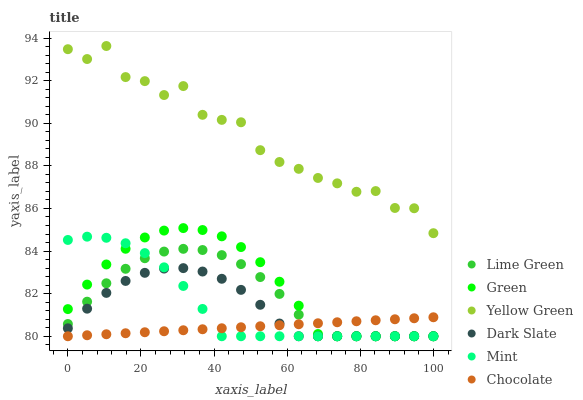Does Chocolate have the minimum area under the curve?
Answer yes or no. Yes. Does Yellow Green have the maximum area under the curve?
Answer yes or no. Yes. Does Lime Green have the minimum area under the curve?
Answer yes or no. No. Does Lime Green have the maximum area under the curve?
Answer yes or no. No. Is Chocolate the smoothest?
Answer yes or no. Yes. Is Yellow Green the roughest?
Answer yes or no. Yes. Is Lime Green the smoothest?
Answer yes or no. No. Is Lime Green the roughest?
Answer yes or no. No. Does Lime Green have the lowest value?
Answer yes or no. Yes. Does Yellow Green have the highest value?
Answer yes or no. Yes. Does Lime Green have the highest value?
Answer yes or no. No. Is Chocolate less than Yellow Green?
Answer yes or no. Yes. Is Yellow Green greater than Mint?
Answer yes or no. Yes. Does Mint intersect Lime Green?
Answer yes or no. Yes. Is Mint less than Lime Green?
Answer yes or no. No. Is Mint greater than Lime Green?
Answer yes or no. No. Does Chocolate intersect Yellow Green?
Answer yes or no. No. 